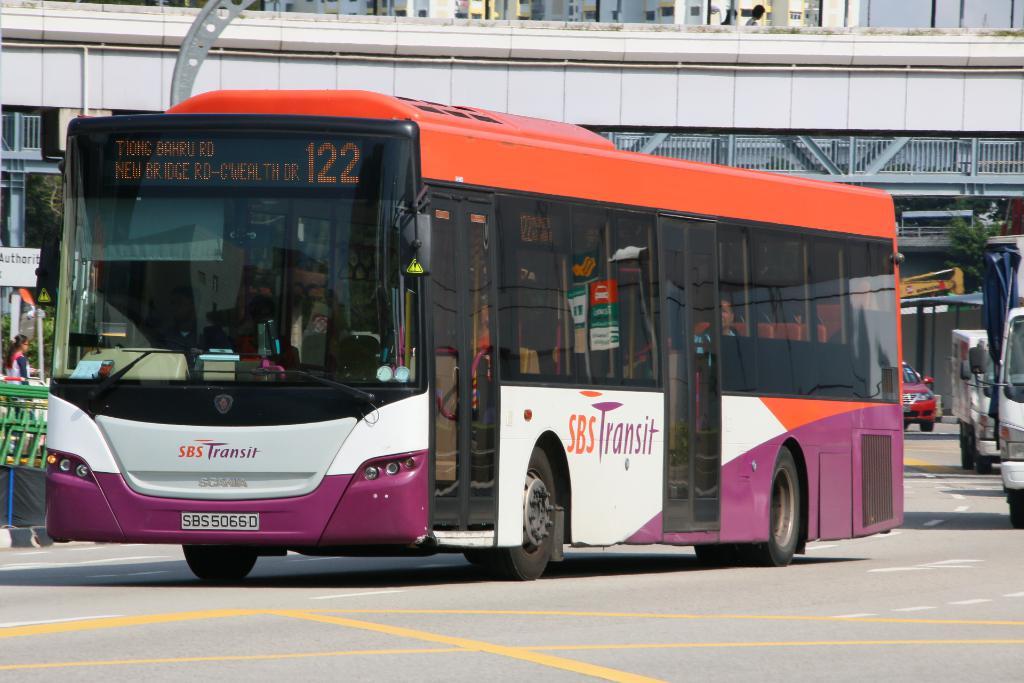What's the bus number?
Make the answer very short. 122. What is the sponsor of the bus?
Offer a terse response. Sbs transit. 